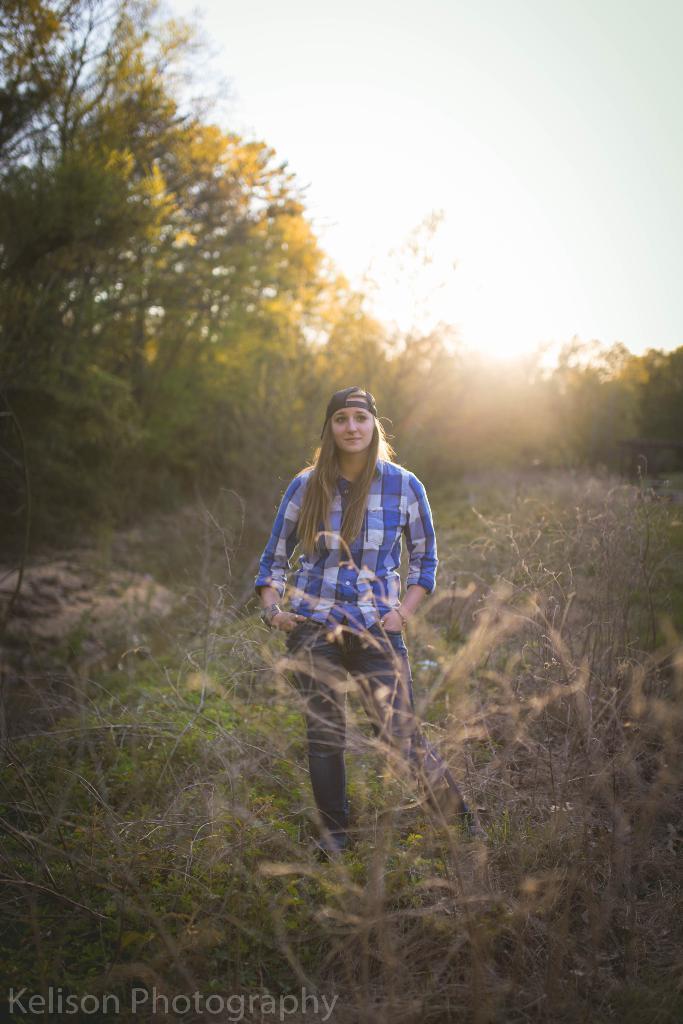Can you describe this image briefly? In this picture we can see a woman on the ground and in the background we can see trees, sky, in the bottom left we can see some text on it. 